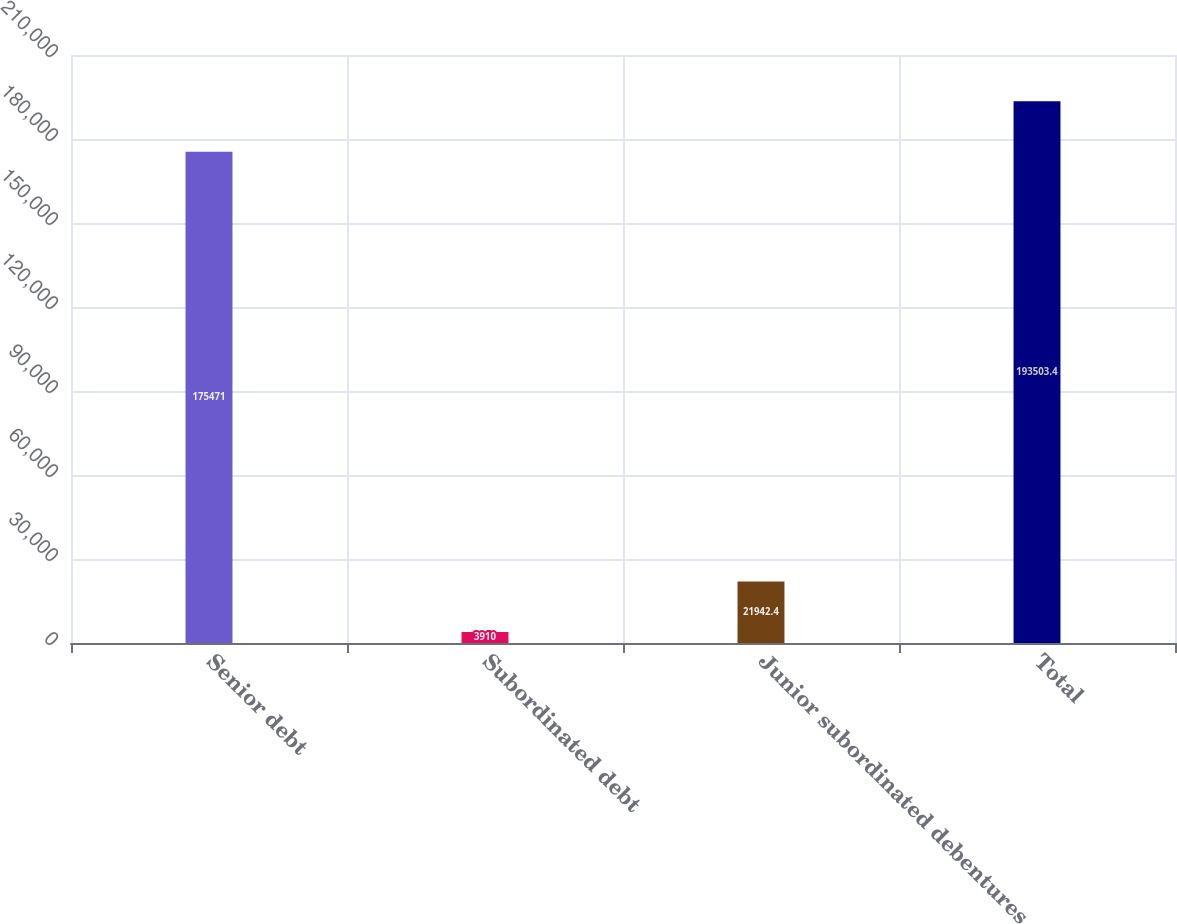<chart> <loc_0><loc_0><loc_500><loc_500><bar_chart><fcel>Senior debt<fcel>Subordinated debt<fcel>Junior subordinated debentures<fcel>Total<nl><fcel>175471<fcel>3910<fcel>21942.4<fcel>193503<nl></chart> 